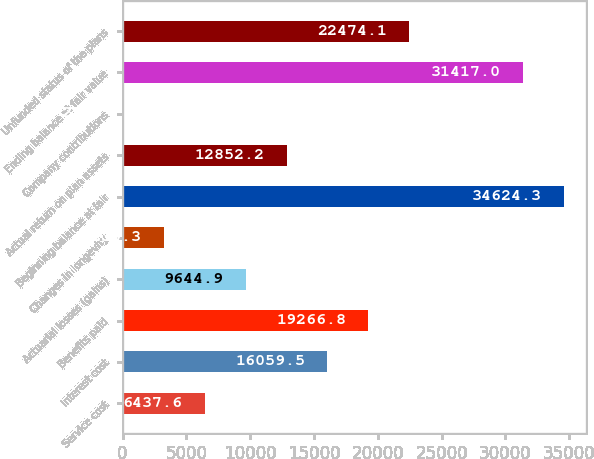Convert chart. <chart><loc_0><loc_0><loc_500><loc_500><bar_chart><fcel>Service cost<fcel>Interest cost<fcel>Benefits paid<fcel>Actuarial losses (gains)<fcel>Changes in longevity<fcel>Beginning balance at fair<fcel>Actual return on plan assets<fcel>Company contributions<fcel>Ending balance at fair value<fcel>Unfunded status of the plans<nl><fcel>6437.6<fcel>16059.5<fcel>19266.8<fcel>9644.9<fcel>3230.3<fcel>34624.3<fcel>12852.2<fcel>23<fcel>31417<fcel>22474.1<nl></chart> 